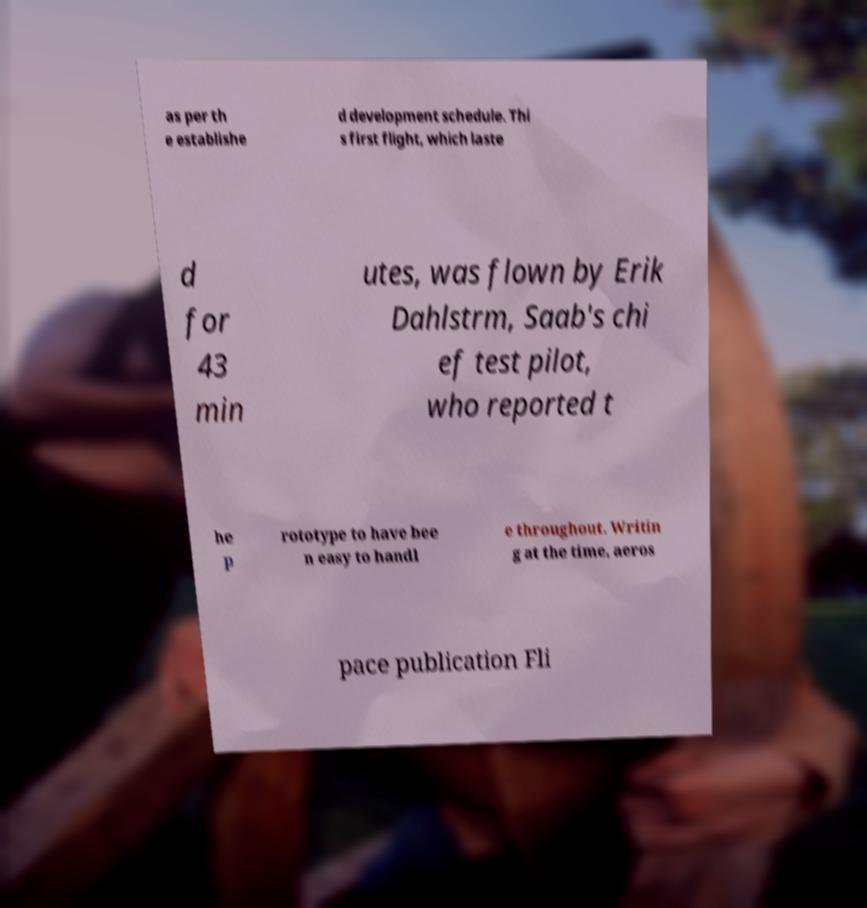What messages or text are displayed in this image? I need them in a readable, typed format. as per th e establishe d development schedule. Thi s first flight, which laste d for 43 min utes, was flown by Erik Dahlstrm, Saab's chi ef test pilot, who reported t he p rototype to have bee n easy to handl e throughout. Writin g at the time, aeros pace publication Fli 